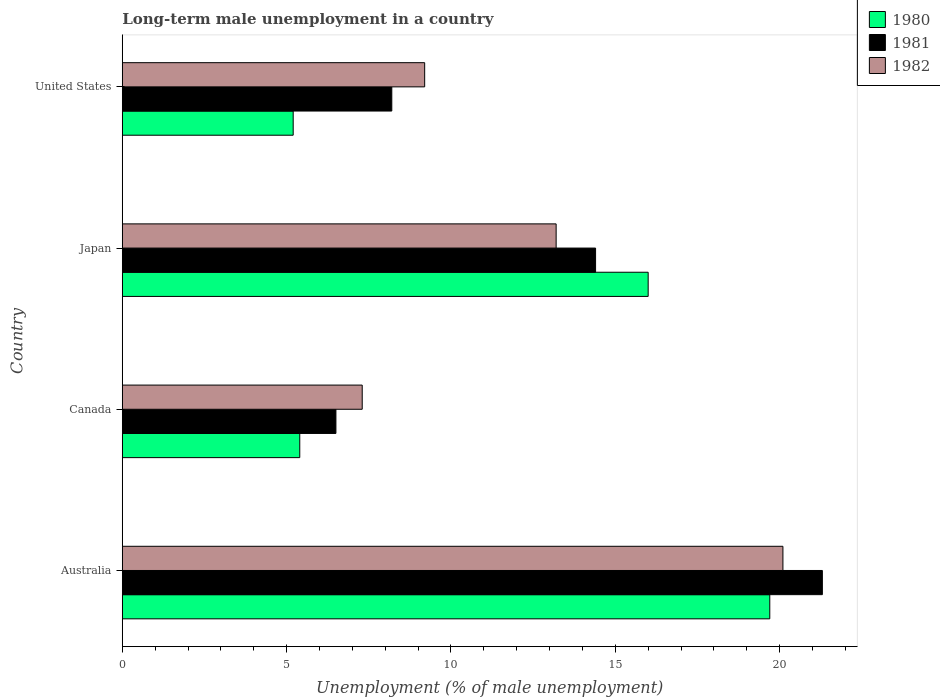How many groups of bars are there?
Offer a very short reply. 4. Are the number of bars on each tick of the Y-axis equal?
Make the answer very short. Yes. How many bars are there on the 4th tick from the top?
Give a very brief answer. 3. How many bars are there on the 1st tick from the bottom?
Make the answer very short. 3. What is the label of the 1st group of bars from the top?
Provide a succinct answer. United States. In how many cases, is the number of bars for a given country not equal to the number of legend labels?
Offer a terse response. 0. What is the percentage of long-term unemployed male population in 1981 in United States?
Your response must be concise. 8.2. Across all countries, what is the maximum percentage of long-term unemployed male population in 1980?
Make the answer very short. 19.7. Across all countries, what is the minimum percentage of long-term unemployed male population in 1981?
Ensure brevity in your answer.  6.5. In which country was the percentage of long-term unemployed male population in 1981 maximum?
Provide a short and direct response. Australia. What is the total percentage of long-term unemployed male population in 1980 in the graph?
Ensure brevity in your answer.  46.3. What is the difference between the percentage of long-term unemployed male population in 1980 in Canada and that in United States?
Offer a terse response. 0.2. What is the difference between the percentage of long-term unemployed male population in 1981 in Canada and the percentage of long-term unemployed male population in 1980 in United States?
Ensure brevity in your answer.  1.3. What is the average percentage of long-term unemployed male population in 1981 per country?
Provide a short and direct response. 12.6. What is the difference between the percentage of long-term unemployed male population in 1980 and percentage of long-term unemployed male population in 1982 in United States?
Your response must be concise. -4. What is the ratio of the percentage of long-term unemployed male population in 1981 in Australia to that in United States?
Make the answer very short. 2.6. Is the difference between the percentage of long-term unemployed male population in 1980 in Japan and United States greater than the difference between the percentage of long-term unemployed male population in 1982 in Japan and United States?
Your answer should be compact. Yes. What is the difference between the highest and the second highest percentage of long-term unemployed male population in 1982?
Your answer should be very brief. 6.9. What is the difference between the highest and the lowest percentage of long-term unemployed male population in 1980?
Your answer should be compact. 14.5. In how many countries, is the percentage of long-term unemployed male population in 1980 greater than the average percentage of long-term unemployed male population in 1980 taken over all countries?
Your answer should be very brief. 2. What does the 3rd bar from the bottom in Australia represents?
Give a very brief answer. 1982. Is it the case that in every country, the sum of the percentage of long-term unemployed male population in 1981 and percentage of long-term unemployed male population in 1982 is greater than the percentage of long-term unemployed male population in 1980?
Your response must be concise. Yes. How many bars are there?
Provide a succinct answer. 12. Are all the bars in the graph horizontal?
Provide a succinct answer. Yes. How many countries are there in the graph?
Your answer should be very brief. 4. Are the values on the major ticks of X-axis written in scientific E-notation?
Give a very brief answer. No. Does the graph contain any zero values?
Make the answer very short. No. Does the graph contain grids?
Offer a terse response. No. How are the legend labels stacked?
Ensure brevity in your answer.  Vertical. What is the title of the graph?
Offer a terse response. Long-term male unemployment in a country. Does "2006" appear as one of the legend labels in the graph?
Your answer should be compact. No. What is the label or title of the X-axis?
Provide a succinct answer. Unemployment (% of male unemployment). What is the Unemployment (% of male unemployment) in 1980 in Australia?
Your response must be concise. 19.7. What is the Unemployment (% of male unemployment) in 1981 in Australia?
Give a very brief answer. 21.3. What is the Unemployment (% of male unemployment) in 1982 in Australia?
Give a very brief answer. 20.1. What is the Unemployment (% of male unemployment) in 1980 in Canada?
Your answer should be compact. 5.4. What is the Unemployment (% of male unemployment) in 1981 in Canada?
Provide a short and direct response. 6.5. What is the Unemployment (% of male unemployment) in 1982 in Canada?
Provide a short and direct response. 7.3. What is the Unemployment (% of male unemployment) of 1981 in Japan?
Provide a short and direct response. 14.4. What is the Unemployment (% of male unemployment) in 1982 in Japan?
Your answer should be compact. 13.2. What is the Unemployment (% of male unemployment) in 1980 in United States?
Give a very brief answer. 5.2. What is the Unemployment (% of male unemployment) in 1981 in United States?
Provide a succinct answer. 8.2. What is the Unemployment (% of male unemployment) in 1982 in United States?
Provide a succinct answer. 9.2. Across all countries, what is the maximum Unemployment (% of male unemployment) of 1980?
Make the answer very short. 19.7. Across all countries, what is the maximum Unemployment (% of male unemployment) of 1981?
Your response must be concise. 21.3. Across all countries, what is the maximum Unemployment (% of male unemployment) in 1982?
Your answer should be compact. 20.1. Across all countries, what is the minimum Unemployment (% of male unemployment) of 1980?
Offer a very short reply. 5.2. Across all countries, what is the minimum Unemployment (% of male unemployment) of 1982?
Your answer should be very brief. 7.3. What is the total Unemployment (% of male unemployment) in 1980 in the graph?
Make the answer very short. 46.3. What is the total Unemployment (% of male unemployment) of 1981 in the graph?
Your answer should be very brief. 50.4. What is the total Unemployment (% of male unemployment) in 1982 in the graph?
Keep it short and to the point. 49.8. What is the difference between the Unemployment (% of male unemployment) of 1981 in Australia and that in Canada?
Ensure brevity in your answer.  14.8. What is the difference between the Unemployment (% of male unemployment) in 1981 in Australia and that in Japan?
Make the answer very short. 6.9. What is the difference between the Unemployment (% of male unemployment) in 1982 in Australia and that in Japan?
Offer a terse response. 6.9. What is the difference between the Unemployment (% of male unemployment) of 1981 in Australia and that in United States?
Provide a short and direct response. 13.1. What is the difference between the Unemployment (% of male unemployment) of 1981 in Canada and that in Japan?
Make the answer very short. -7.9. What is the difference between the Unemployment (% of male unemployment) of 1982 in Canada and that in Japan?
Ensure brevity in your answer.  -5.9. What is the difference between the Unemployment (% of male unemployment) in 1982 in Japan and that in United States?
Provide a succinct answer. 4. What is the difference between the Unemployment (% of male unemployment) of 1980 in Australia and the Unemployment (% of male unemployment) of 1981 in Canada?
Make the answer very short. 13.2. What is the difference between the Unemployment (% of male unemployment) of 1980 in Australia and the Unemployment (% of male unemployment) of 1981 in Japan?
Your answer should be very brief. 5.3. What is the difference between the Unemployment (% of male unemployment) in 1980 in Australia and the Unemployment (% of male unemployment) in 1982 in United States?
Ensure brevity in your answer.  10.5. What is the difference between the Unemployment (% of male unemployment) of 1981 in Australia and the Unemployment (% of male unemployment) of 1982 in United States?
Provide a succinct answer. 12.1. What is the difference between the Unemployment (% of male unemployment) in 1980 in Canada and the Unemployment (% of male unemployment) in 1981 in United States?
Give a very brief answer. -2.8. What is the difference between the Unemployment (% of male unemployment) in 1980 in Japan and the Unemployment (% of male unemployment) in 1981 in United States?
Make the answer very short. 7.8. What is the difference between the Unemployment (% of male unemployment) of 1981 in Japan and the Unemployment (% of male unemployment) of 1982 in United States?
Offer a terse response. 5.2. What is the average Unemployment (% of male unemployment) in 1980 per country?
Provide a succinct answer. 11.57. What is the average Unemployment (% of male unemployment) of 1982 per country?
Offer a very short reply. 12.45. What is the difference between the Unemployment (% of male unemployment) in 1980 and Unemployment (% of male unemployment) in 1981 in Australia?
Provide a short and direct response. -1.6. What is the difference between the Unemployment (% of male unemployment) in 1981 and Unemployment (% of male unemployment) in 1982 in Canada?
Give a very brief answer. -0.8. What is the difference between the Unemployment (% of male unemployment) in 1980 and Unemployment (% of male unemployment) in 1982 in Japan?
Ensure brevity in your answer.  2.8. What is the difference between the Unemployment (% of male unemployment) in 1981 and Unemployment (% of male unemployment) in 1982 in Japan?
Offer a very short reply. 1.2. What is the difference between the Unemployment (% of male unemployment) of 1980 and Unemployment (% of male unemployment) of 1981 in United States?
Keep it short and to the point. -3. What is the difference between the Unemployment (% of male unemployment) in 1981 and Unemployment (% of male unemployment) in 1982 in United States?
Make the answer very short. -1. What is the ratio of the Unemployment (% of male unemployment) of 1980 in Australia to that in Canada?
Provide a succinct answer. 3.65. What is the ratio of the Unemployment (% of male unemployment) of 1981 in Australia to that in Canada?
Your answer should be compact. 3.28. What is the ratio of the Unemployment (% of male unemployment) in 1982 in Australia to that in Canada?
Your response must be concise. 2.75. What is the ratio of the Unemployment (% of male unemployment) in 1980 in Australia to that in Japan?
Offer a terse response. 1.23. What is the ratio of the Unemployment (% of male unemployment) of 1981 in Australia to that in Japan?
Your answer should be compact. 1.48. What is the ratio of the Unemployment (% of male unemployment) in 1982 in Australia to that in Japan?
Provide a succinct answer. 1.52. What is the ratio of the Unemployment (% of male unemployment) in 1980 in Australia to that in United States?
Keep it short and to the point. 3.79. What is the ratio of the Unemployment (% of male unemployment) of 1981 in Australia to that in United States?
Your response must be concise. 2.6. What is the ratio of the Unemployment (% of male unemployment) in 1982 in Australia to that in United States?
Offer a terse response. 2.18. What is the ratio of the Unemployment (% of male unemployment) in 1980 in Canada to that in Japan?
Offer a very short reply. 0.34. What is the ratio of the Unemployment (% of male unemployment) of 1981 in Canada to that in Japan?
Your answer should be very brief. 0.45. What is the ratio of the Unemployment (% of male unemployment) in 1982 in Canada to that in Japan?
Keep it short and to the point. 0.55. What is the ratio of the Unemployment (% of male unemployment) in 1980 in Canada to that in United States?
Your answer should be compact. 1.04. What is the ratio of the Unemployment (% of male unemployment) of 1981 in Canada to that in United States?
Keep it short and to the point. 0.79. What is the ratio of the Unemployment (% of male unemployment) of 1982 in Canada to that in United States?
Your response must be concise. 0.79. What is the ratio of the Unemployment (% of male unemployment) of 1980 in Japan to that in United States?
Make the answer very short. 3.08. What is the ratio of the Unemployment (% of male unemployment) in 1981 in Japan to that in United States?
Your response must be concise. 1.76. What is the ratio of the Unemployment (% of male unemployment) of 1982 in Japan to that in United States?
Provide a short and direct response. 1.43. What is the difference between the highest and the lowest Unemployment (% of male unemployment) in 1980?
Keep it short and to the point. 14.5. 